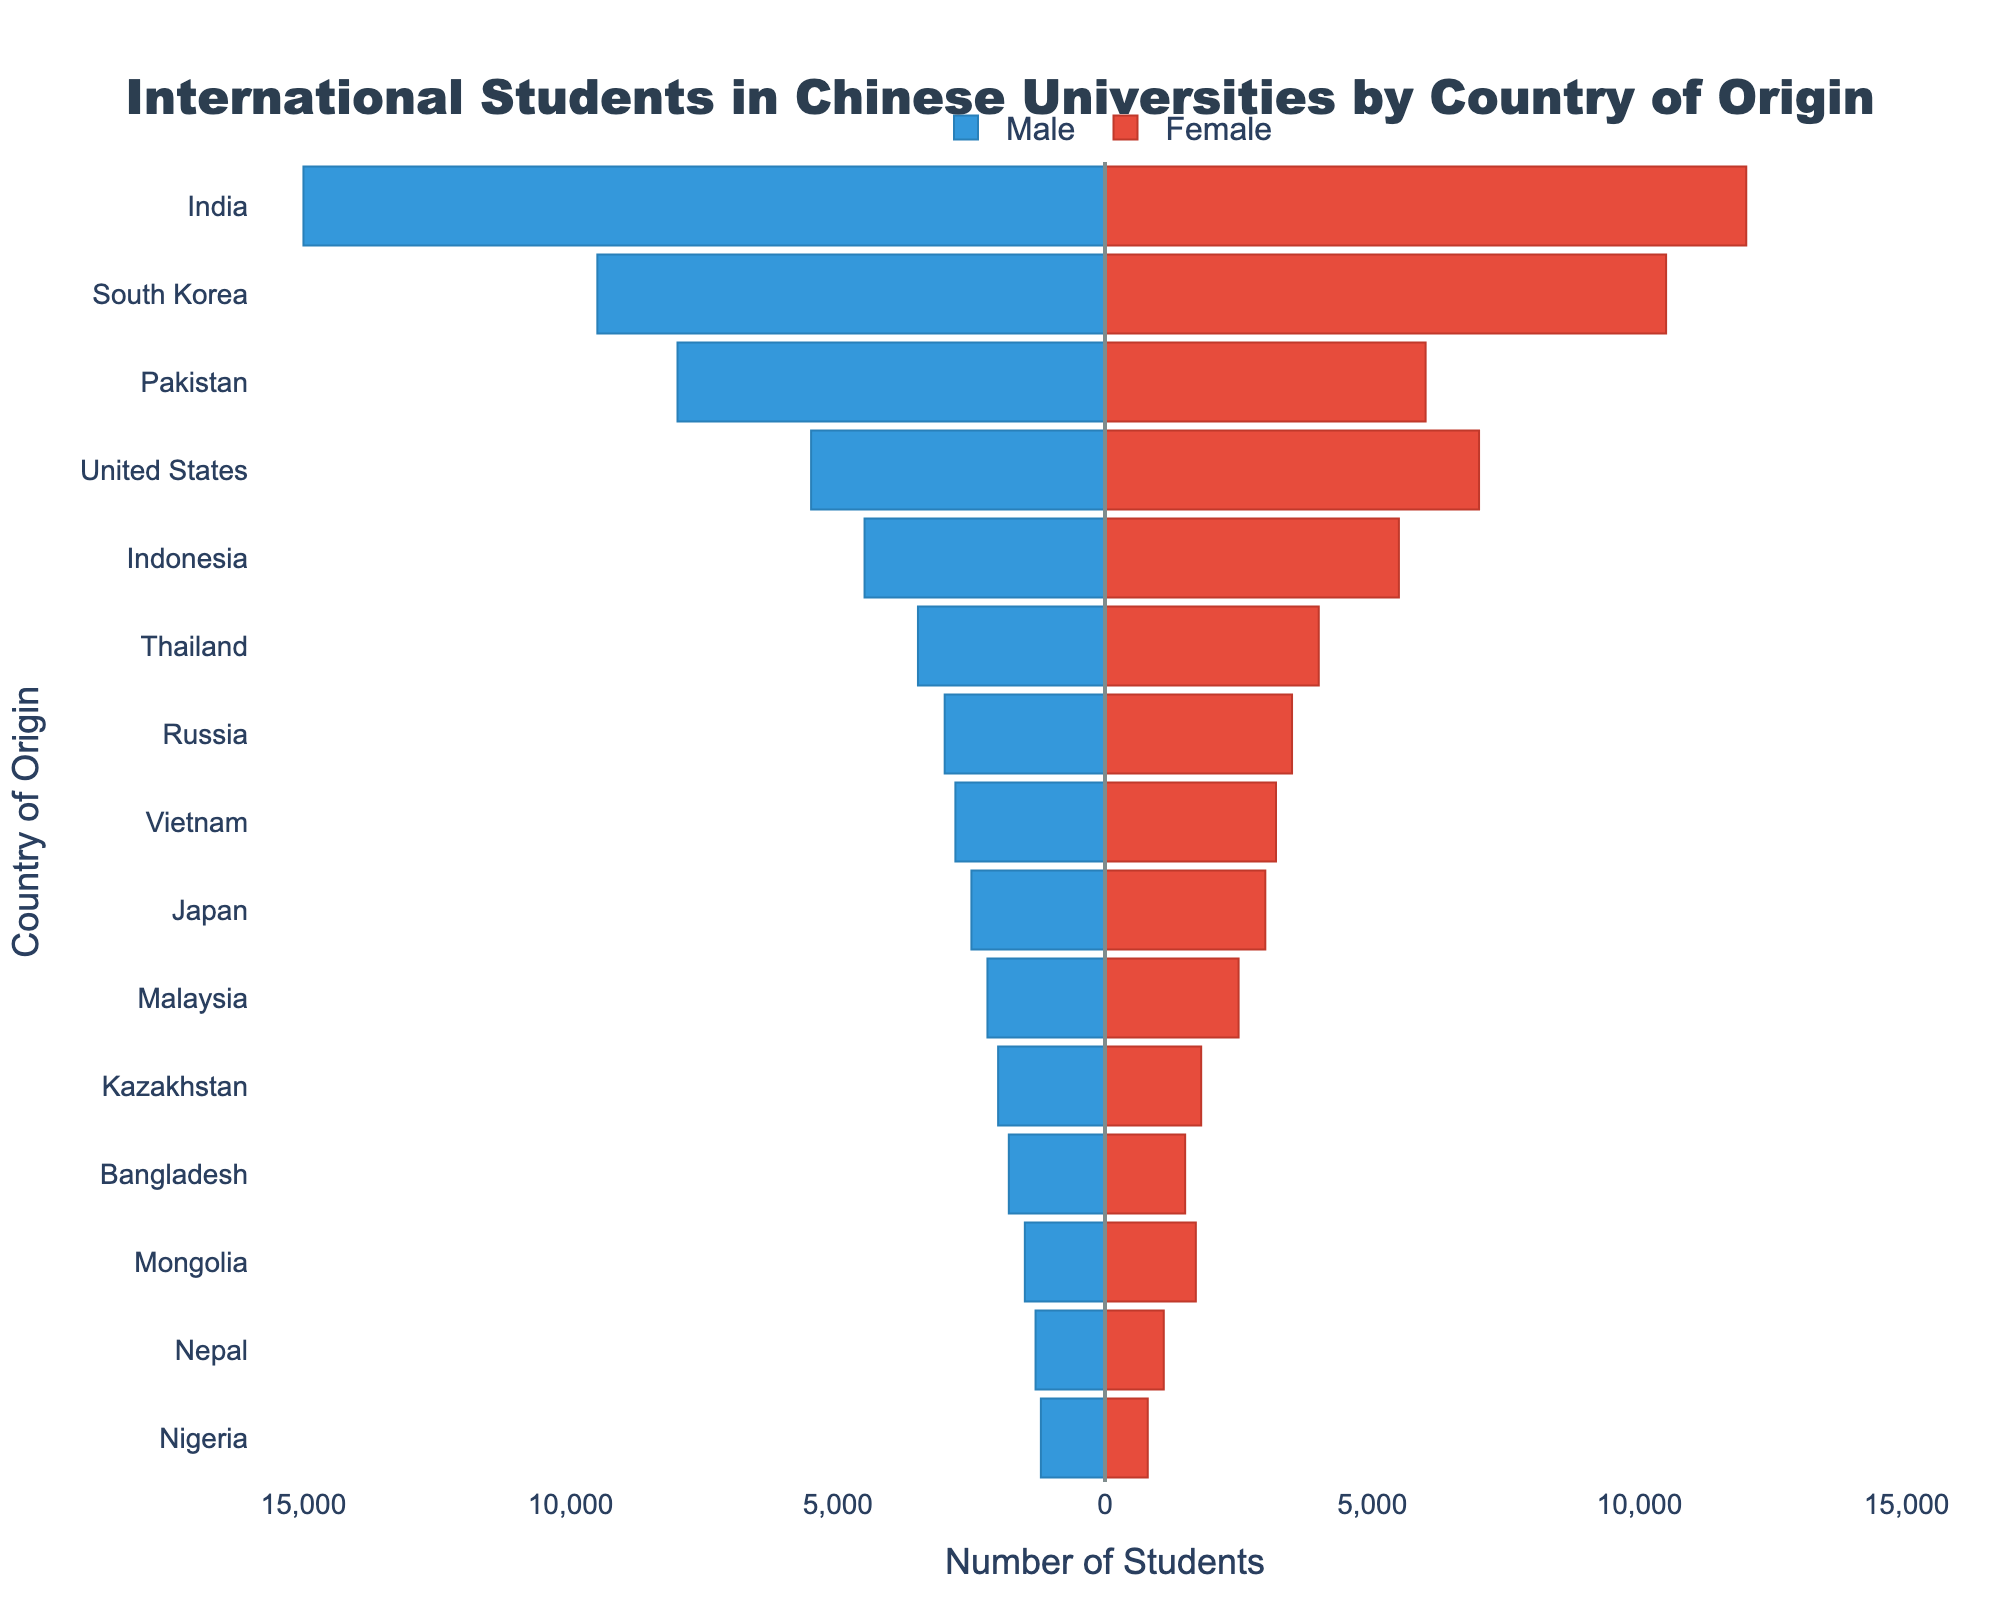What is the title of the figure? The title of the figure is typically displayed at the top of the chart. The visual information indicates it shows "International Students in Chinese Universities by Country of Origin".
Answer: International Students in Chinese Universities by Country of Origin Which country has the highest number of male international students in Chinese universities? By examining the left side of the population pyramid (blue bars), the longest bar represents India, indicating it has the highest number of male students.
Answer: India What is the total number of students (both male and female) from Indonesia? The number of male and female students from Indonesia can be summed up. The data shows 4,500 males and 5,500 females, which sums to a total of 10,000 students.
Answer: 10,000 Which country has more female students, South Korea or the United States? By comparing the lengths of the red bars for South Korea and the United States, we see that the bar for South Korea (10,500) is longer than the bar for the United States (7,000).
Answer: South Korea What is the difference in the number of male students between Pakistan and Nigeria? The number of male students from Pakistan is 8,000 and from Nigeria is 1,200. Subtracting these, 8,000 - 1,200, gives a difference of 6,800.
Answer: 6,800 How many countries have more than 3,000 female students? By counting the countries with red bars extending beyond the 3,000 mark on the x-axis, we see six countries: India, South Korea, United States, Indonesia, Thailand, and Russia.
Answer: 6 Are there more countries with a higher number of male students or female students above 5,000? On the male side, more than 5,000 students come from four countries: India, South Korea, Pakistan, and the United States. On the female side, only India and South Korea exceed 5,000. Therefore, there are more countries with higher male students above 5,000.
Answer: Male Which country has the smallest student population in total? By observing the total length of bars (both red and blue) for each country, Nigeria has the smallest combined length indicating the smallest total student population.
Answer: Nigeria What is the average number of male students from the top three countries with the highest number of males? The top three countries with the highest number of male students are India (15,000), South Korea (9,500), and Pakistan (8,000). The average can be calculated as (15,000 + 9,500 + 8,000) / 3 = 10,833.33.
Answer: 10,833.33 